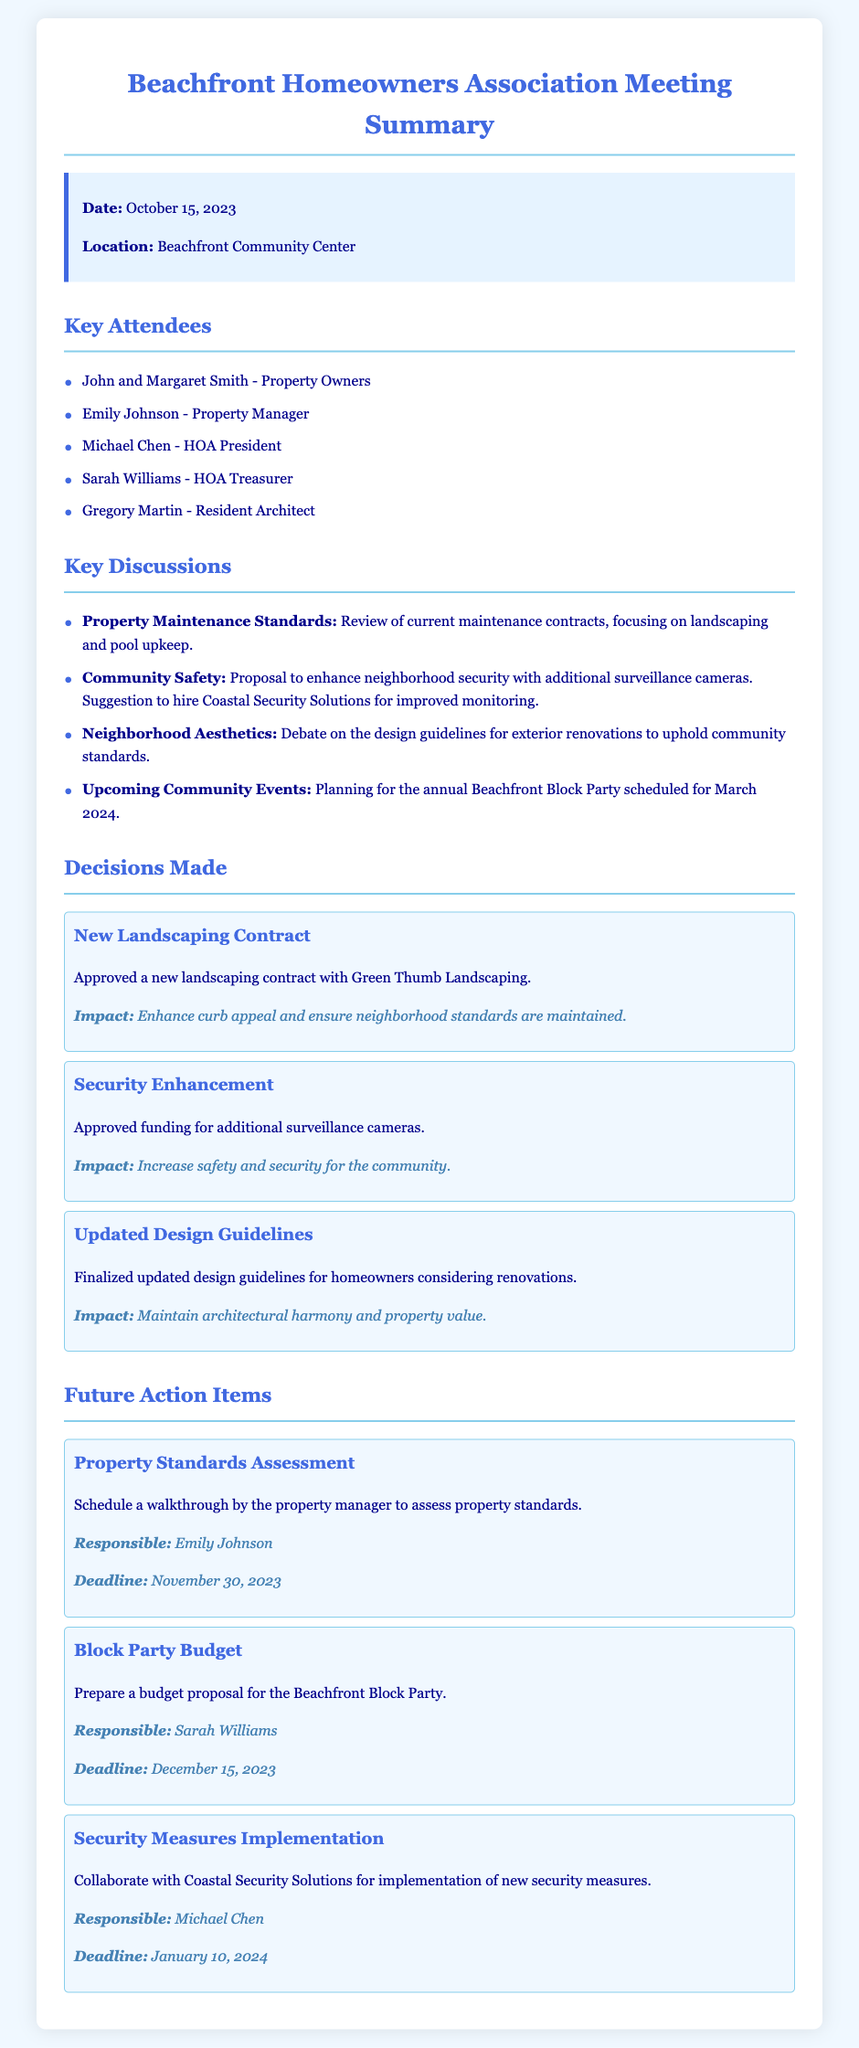what is the date of the meeting? The date is listed in the document under the info section, specifically mentioning when the meeting took place.
Answer: October 15, 2023 who is the HOA President? The HOA President is mentioned under the key attendees section, indicating their role within the homeowners association.
Answer: Michael Chen what is the name of the new landscaping company? The new landscaping contract is specifically approved for a company, which is detailed under decisions made.
Answer: Green Thumb Landscaping what is the deadline for the property standards assessment? The deadline for the property standards assessment is mentioned in the action items section, indicating when it needs to be completed.
Answer: November 30, 2023 what is one of the impacts of the new landscaping contract? The impact of the new landscaping contract is described in terms of its benefits to the neighborhood, which clarifies its importance.
Answer: Enhance curb appeal what security measure was approved during the meeting? The meeting resulted in a specific decision regarding security, which is detailed as a funding approval in the decisions made section.
Answer: Additional surveillance cameras who is responsible for preparing the budget for the Beachfront Block Party? The document lists who is tasked with preparing the budget proposal under future action items, identifying the responsible party.
Answer: Sarah Williams what is the deadline for collaborating with Coastal Security Solutions? The exact deadline for implementing new security measures is outlined in the action items section, specifying when it should be addressed.
Answer: January 10, 2024 what type of event is planned for March 2024? The type of event is described in the key discussions section, indicating a communal gathering that is being organized.
Answer: Beachfront Block Party 